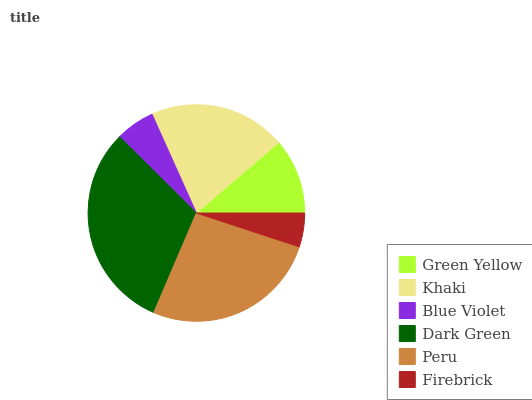Is Firebrick the minimum?
Answer yes or no. Yes. Is Dark Green the maximum?
Answer yes or no. Yes. Is Khaki the minimum?
Answer yes or no. No. Is Khaki the maximum?
Answer yes or no. No. Is Khaki greater than Green Yellow?
Answer yes or no. Yes. Is Green Yellow less than Khaki?
Answer yes or no. Yes. Is Green Yellow greater than Khaki?
Answer yes or no. No. Is Khaki less than Green Yellow?
Answer yes or no. No. Is Khaki the high median?
Answer yes or no. Yes. Is Green Yellow the low median?
Answer yes or no. Yes. Is Peru the high median?
Answer yes or no. No. Is Blue Violet the low median?
Answer yes or no. No. 